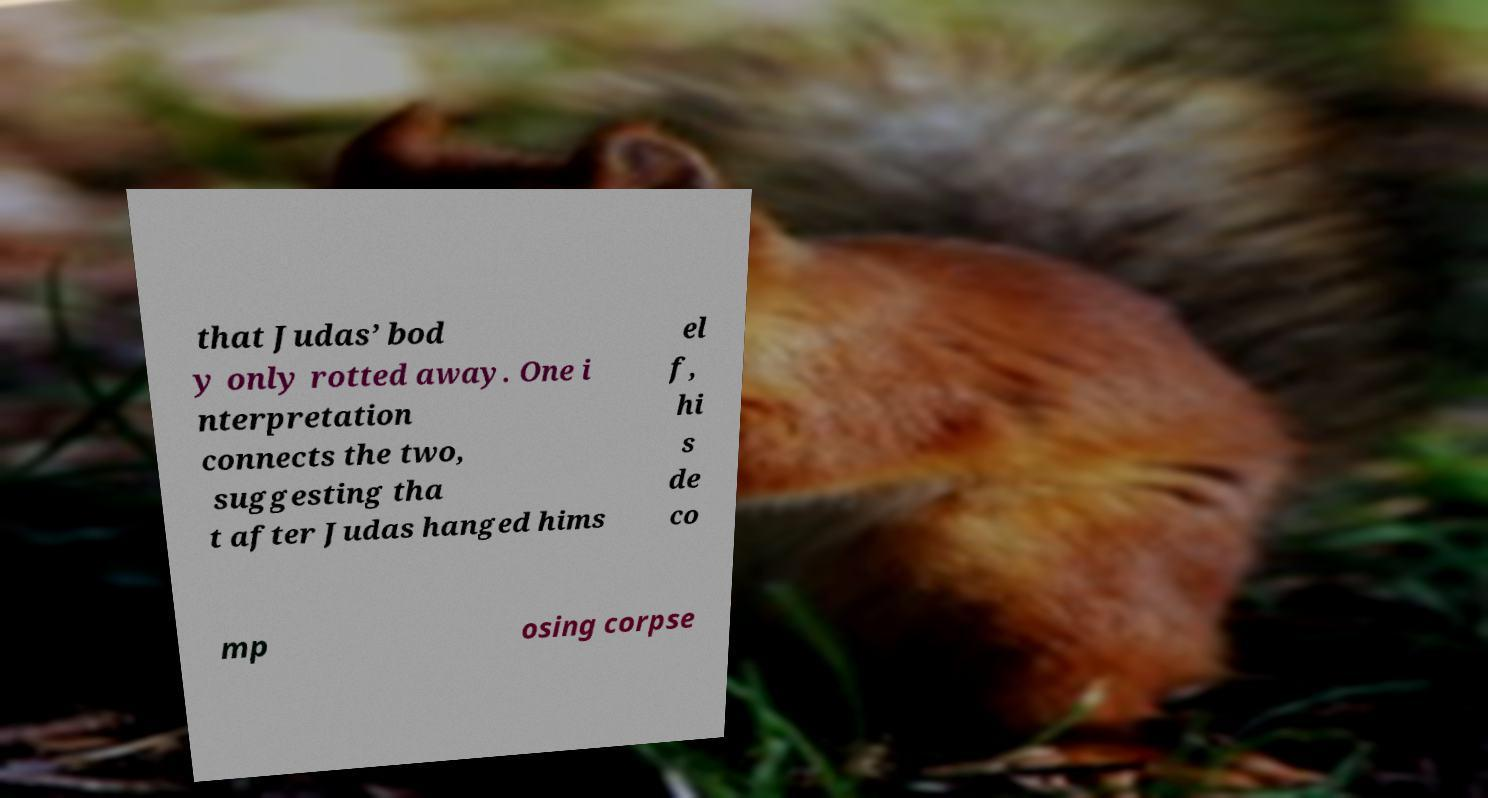What messages or text are displayed in this image? I need them in a readable, typed format. that Judas’ bod y only rotted away. One i nterpretation connects the two, suggesting tha t after Judas hanged hims el f, hi s de co mp osing corpse 